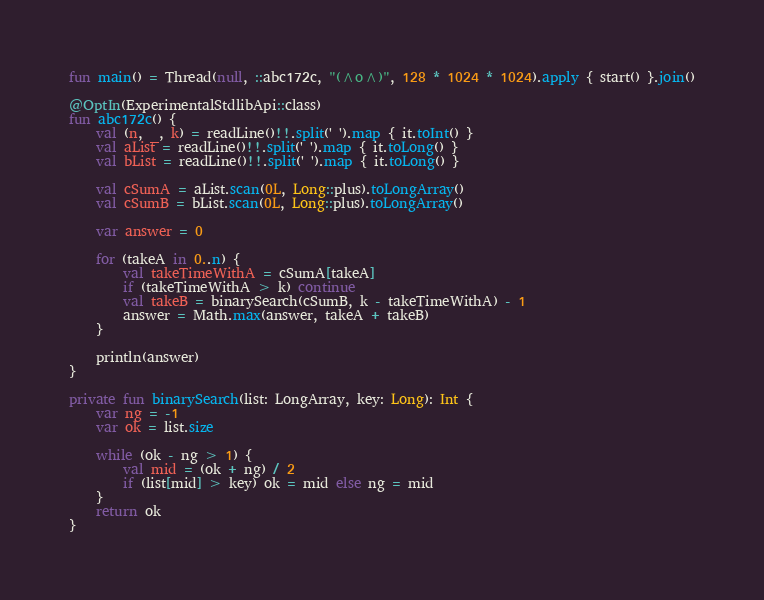Convert code to text. <code><loc_0><loc_0><loc_500><loc_500><_Kotlin_>fun main() = Thread(null, ::abc172c, "(^o^)", 128 * 1024 * 1024).apply { start() }.join()

@OptIn(ExperimentalStdlibApi::class)
fun abc172c() {
    val (n, _, k) = readLine()!!.split(' ').map { it.toInt() }
    val aList = readLine()!!.split(' ').map { it.toLong() }
    val bList = readLine()!!.split(' ').map { it.toLong() }

    val cSumA = aList.scan(0L, Long::plus).toLongArray()
    val cSumB = bList.scan(0L, Long::plus).toLongArray()

    var answer = 0

    for (takeA in 0..n) {
        val takeTimeWithA = cSumA[takeA]
        if (takeTimeWithA > k) continue
        val takeB = binarySearch(cSumB, k - takeTimeWithA) - 1
        answer = Math.max(answer, takeA + takeB)
    }

    println(answer)
}

private fun binarySearch(list: LongArray, key: Long): Int {
    var ng = -1
    var ok = list.size

    while (ok - ng > 1) {
        val mid = (ok + ng) / 2
        if (list[mid] > key) ok = mid else ng = mid
    }
    return ok
}
</code> 